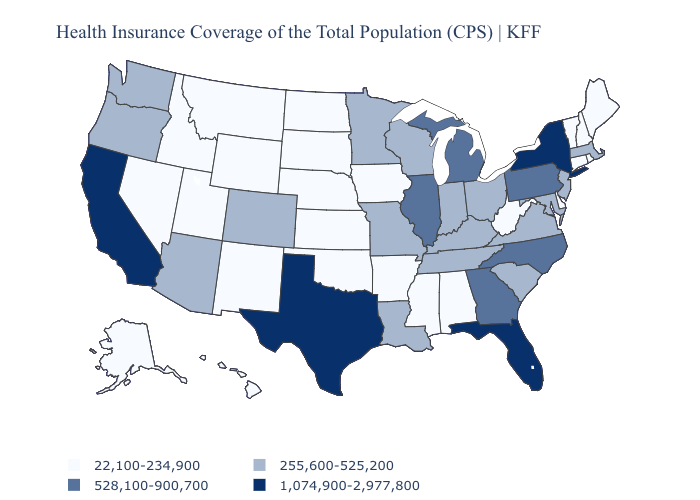What is the value of California?
Short answer required. 1,074,900-2,977,800. Which states have the highest value in the USA?
Quick response, please. California, Florida, New York, Texas. Does Maine have the highest value in the USA?
Short answer required. No. Name the states that have a value in the range 22,100-234,900?
Give a very brief answer. Alabama, Alaska, Arkansas, Connecticut, Delaware, Hawaii, Idaho, Iowa, Kansas, Maine, Mississippi, Montana, Nebraska, Nevada, New Hampshire, New Mexico, North Dakota, Oklahoma, Rhode Island, South Dakota, Utah, Vermont, West Virginia, Wyoming. Name the states that have a value in the range 22,100-234,900?
Write a very short answer. Alabama, Alaska, Arkansas, Connecticut, Delaware, Hawaii, Idaho, Iowa, Kansas, Maine, Mississippi, Montana, Nebraska, Nevada, New Hampshire, New Mexico, North Dakota, Oklahoma, Rhode Island, South Dakota, Utah, Vermont, West Virginia, Wyoming. What is the value of Arkansas?
Quick response, please. 22,100-234,900. Does Maryland have the lowest value in the USA?
Give a very brief answer. No. What is the value of Rhode Island?
Answer briefly. 22,100-234,900. What is the highest value in states that border Nebraska?
Write a very short answer. 255,600-525,200. Does the map have missing data?
Concise answer only. No. Is the legend a continuous bar?
Give a very brief answer. No. What is the lowest value in the MidWest?
Concise answer only. 22,100-234,900. Which states have the highest value in the USA?
Concise answer only. California, Florida, New York, Texas. Among the states that border Kentucky , does Illinois have the lowest value?
Give a very brief answer. No. What is the highest value in the West ?
Keep it brief. 1,074,900-2,977,800. 